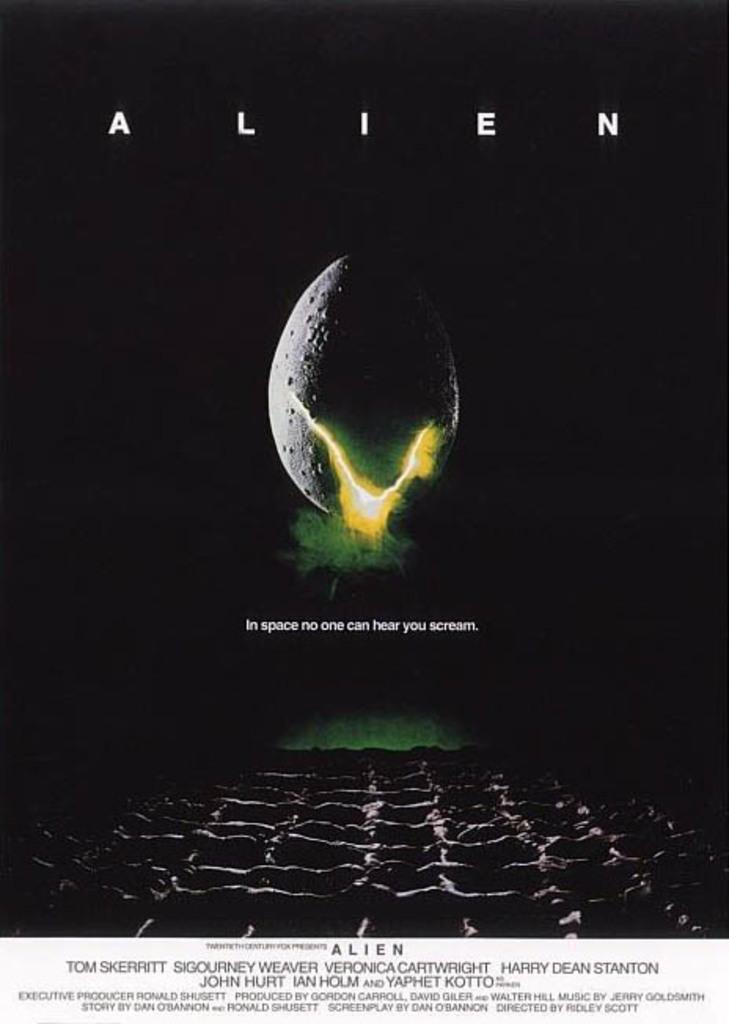<image>
Give a short and clear explanation of the subsequent image. a post of the movie alien with tom skerrit 